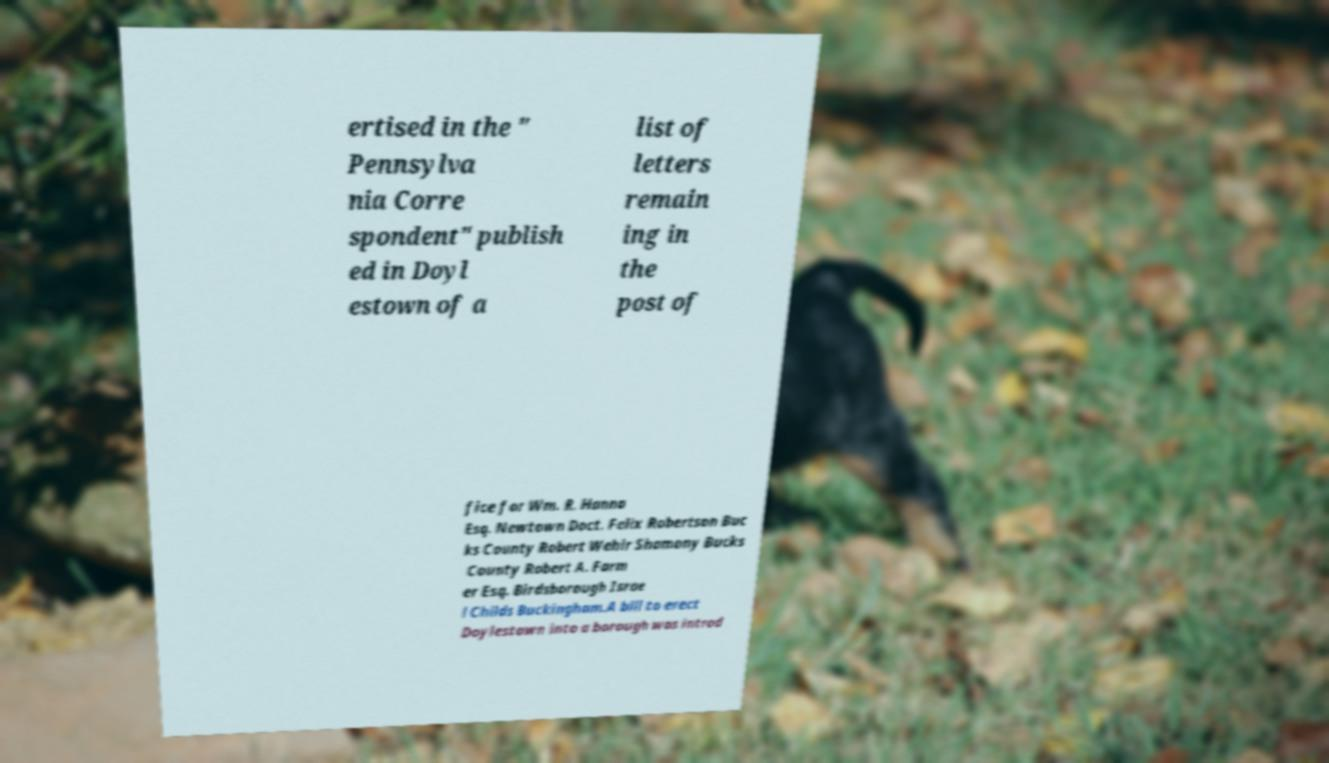Could you extract and type out the text from this image? ertised in the " Pennsylva nia Corre spondent" publish ed in Doyl estown of a list of letters remain ing in the post of fice for Wm. R. Hanna Esq. Newtown Doct. Felix Robertson Buc ks County Robert Wehir Shamony Bucks County Robert A. Farm er Esq. Birdsborough Israe l Childs Buckingham.A bill to erect Doylestown into a borough was introd 